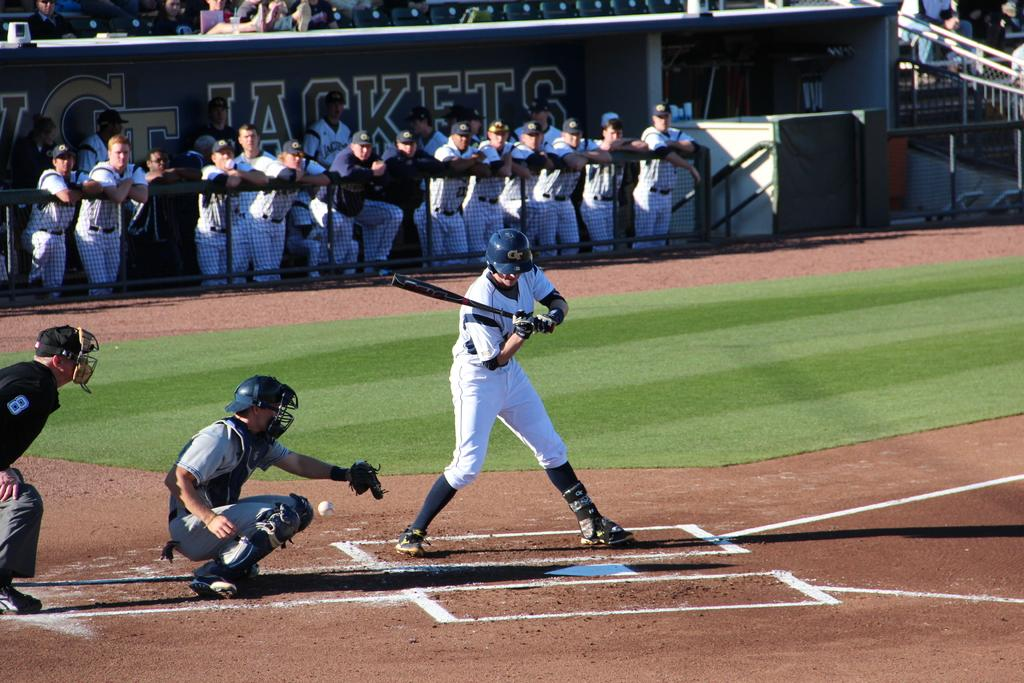<image>
Render a clear and concise summary of the photo. a baseball game with jackets written in the dugout 